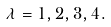Convert formula to latex. <formula><loc_0><loc_0><loc_500><loc_500>\lambda & = 1 , 2 , 3 , 4 .</formula> 